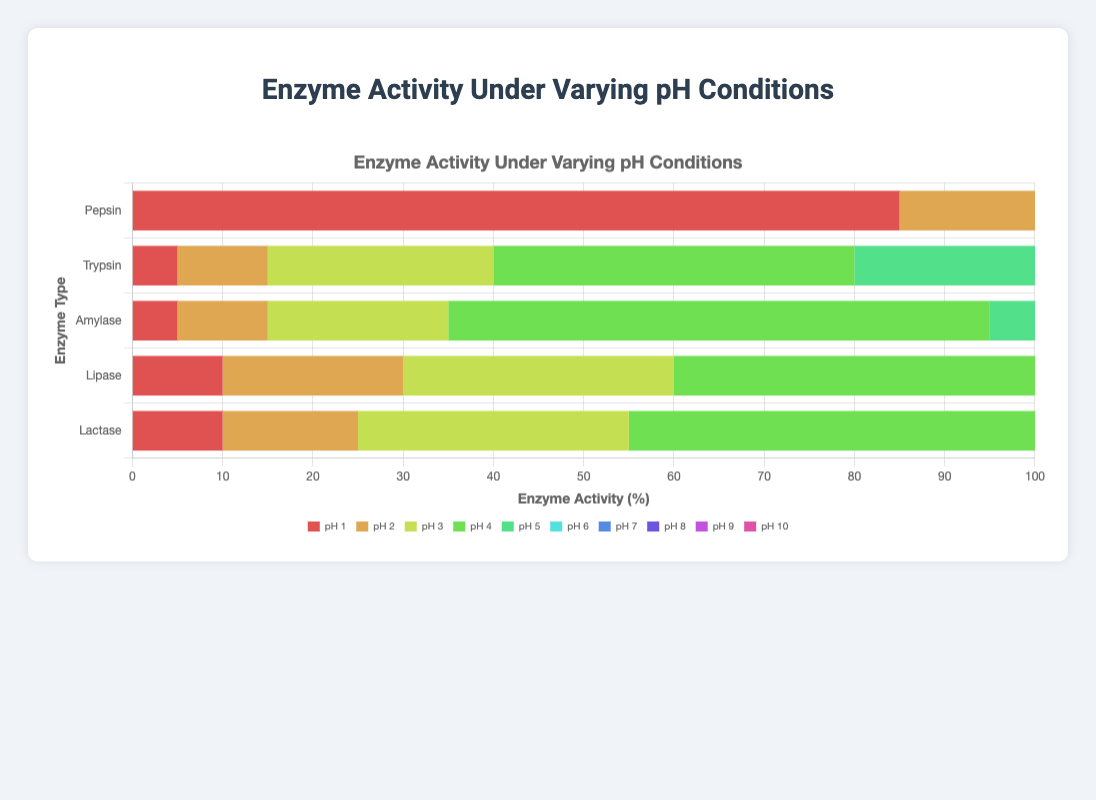What is the enzyme with the highest activity at pH 1? To find the enzyme with the highest activity at pH 1, look at the bar segments labeled "pH 1" across all enzyme bars and compare their lengths. Pepsin has the longest bar for pH 1.
Answer: Pepsin Which enzyme shows the highest overall activity at pH 7? Look for the longest bar segment labeled "pH 7" among all enzymes. Both Lipase and Lactase have the longest bar segments for pH 7 at 90 units each.
Answer: Lipase and Lactase What is the total enzyme activity for Amylase across all pH levels? Add up the activity values for Amylase at each pH level: 5 + 10 + 20 + 60 + 80 + 70 + 50 + 40 + 20 + 10 = 365.
Answer: 365 Compare Pepsin and Trypsin: Which enzyme has higher activity at pH 5? Examine the bar segments labeled "pH 5" for both Pepsin and Trypsin. Trypsin's bar segment for pH 5 is longer at 55 units compared to Pepsin's 10 units.
Answer: Trypsin Which enzyme has zero activity from pH 7 onwards, and what is the highest pH level this occurs at? Identify the enzyme with a series of zeros from pH 7 to pH 10. Pepsin shows zero activity at all these pH levels, with the highest being pH 10.
Answer: Pepsin, pH 10 At which pH level does Lipase have its peak activity, and what is the activity value? Observe the segments across the Lipase bar to find the peak (longest) segment. Lipase's peak activity is at pH 7 with an activity of 90 units.
Answer: pH 7, 90 units Which enzyme has the least variance in activity levels across different pH values? Explain the reasoning. Calculate the variance by observing the spread of values for each enzyme across pH levels. Amylase has relatively moderate activity across all pH levels without drastic peaks or drops, indicating the least variance.
Answer: Amylase 